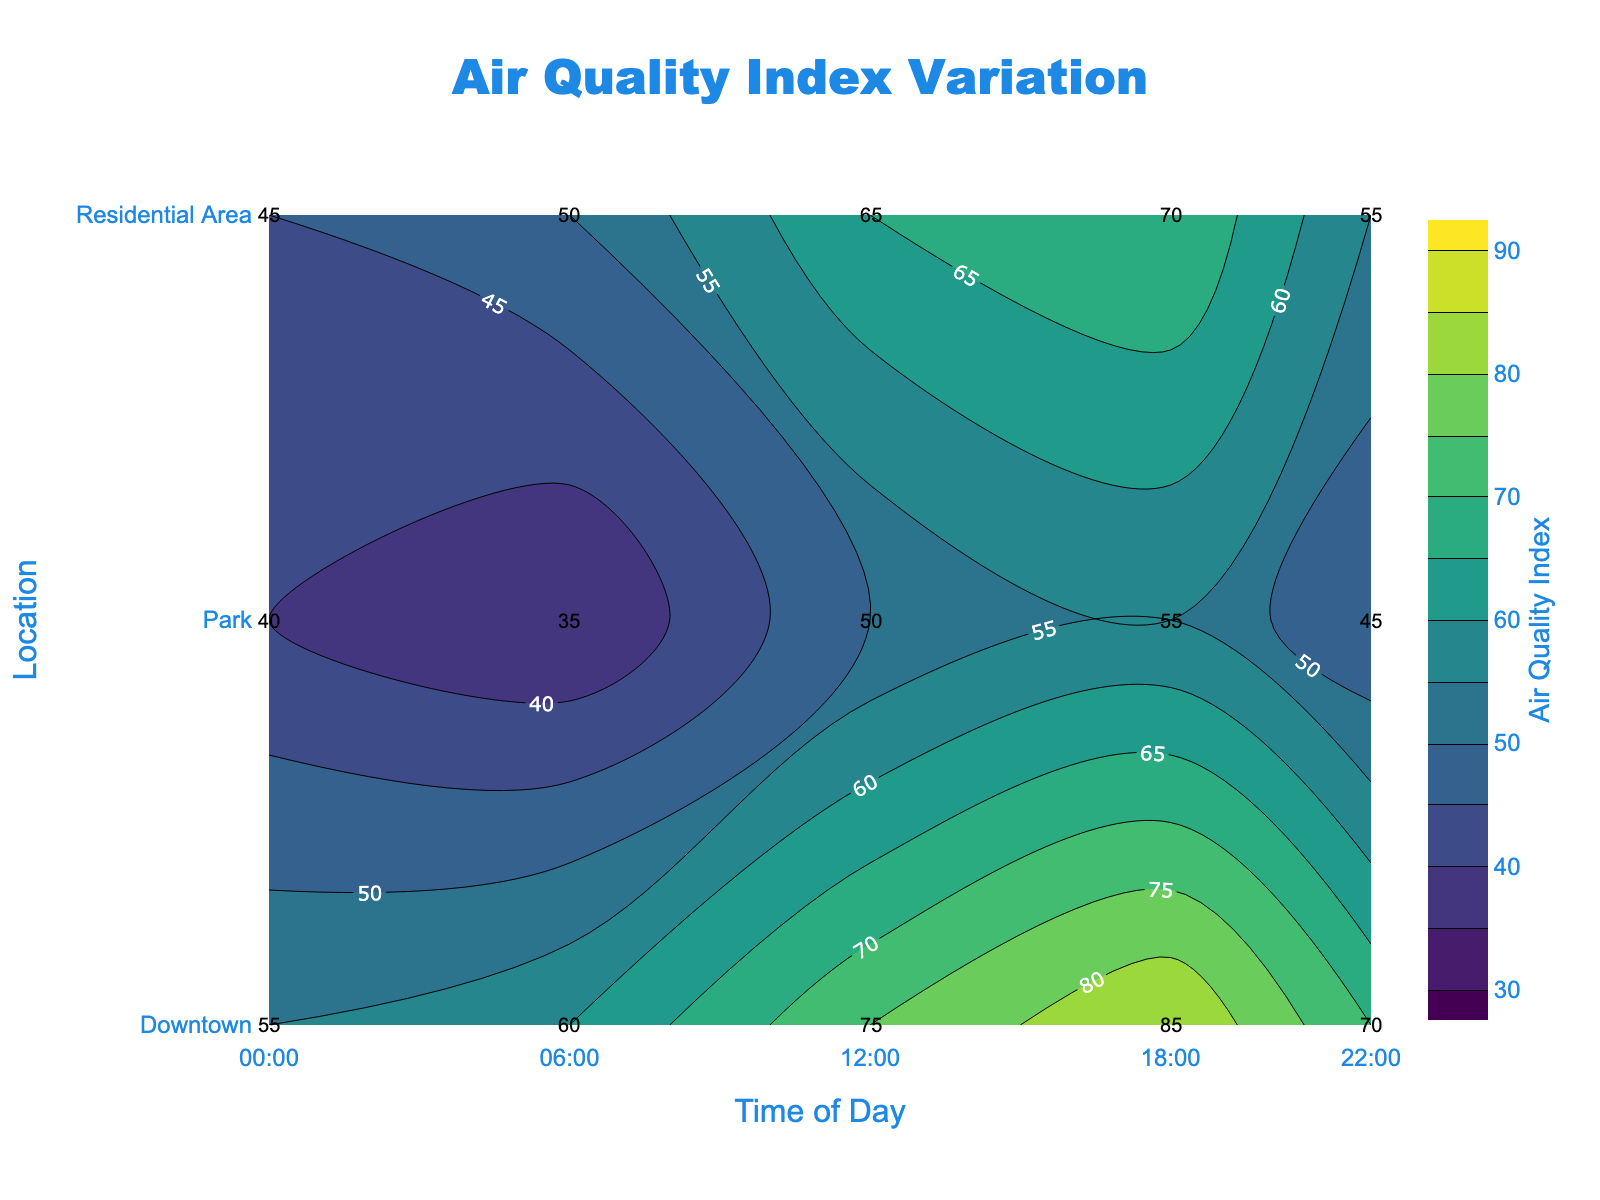What is the title of the plot? The title is positioned at the top center of the plot, and it reads "Air Quality Index Variation".
Answer: Air Quality Index Variation Which location has the highest Air Quality Index at 12:00? At 12:00, marked on the x-axis, the highest Air Quality Index values are represented. By comparing the labels, Downtown has the value of 75, which is higher than the other values.
Answer: Downtown How does the Air Quality Index at Park change from 00:00 to 18:00? The Air Quality Index at Park starts at 40 at 00:00, decreases to 35 at 06:00, increases to 50 at 12:00, then rises further to 55 at 18:00.
Answer: 40 → 35 → 50 → 55 What is the average Air Quality Index in the Residential Area across all times? The values for the Residential Area are 45, 50, 65, 70, and 55. Summing these values gives 285, and dividing by the number of data points (5), the average is 57.
Answer: 57 Which time of day records the lowest Air Quality Index at Downtown? Observing the Air Quality Index values at Downtown across different times, 00:00 has the lowest value of 55.
Answer: 00:00 At 06:00, how do the Air Quality Index values for Downtown and the Residential Area compare? At 06:00, Downtown has an Air Quality Index of 60, and the Residential Area has 50. Comparing the two, Downtown has a higher value.
Answer: Downtown > Residential Area Which location shows the least variation in Air Quality Index throughout the day? By checking the delta between the maximum and minimum values for each location: Downtown (85-55=30), Park (55-35=20), Residential Area (70-45=25). Park has the smallest variation.
Answer: Park How many contour lines are shown in the plot? Contour lines represent intervals of 5, starting from 30 to 90. Counting these intervals, we have 13 contour lines.
Answer: 13 What is the Air Quality Index in the Residential Area at 22:00? Referring to the Residential Area at 22:00, the Air Quality Index value is 55.
Answer: 55 